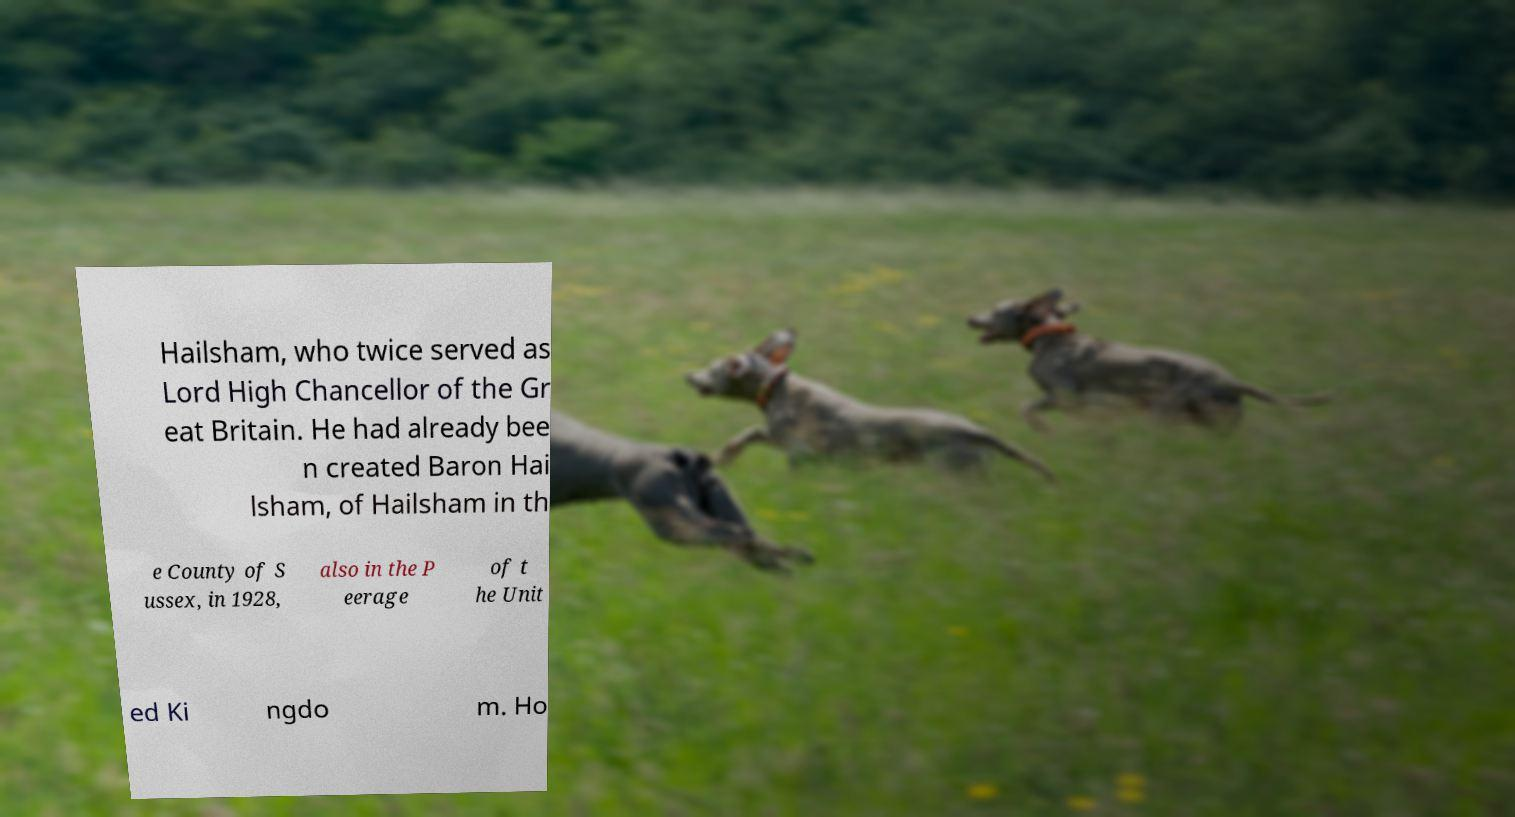Could you extract and type out the text from this image? Hailsham, who twice served as Lord High Chancellor of the Gr eat Britain. He had already bee n created Baron Hai lsham, of Hailsham in th e County of S ussex, in 1928, also in the P eerage of t he Unit ed Ki ngdo m. Ho 